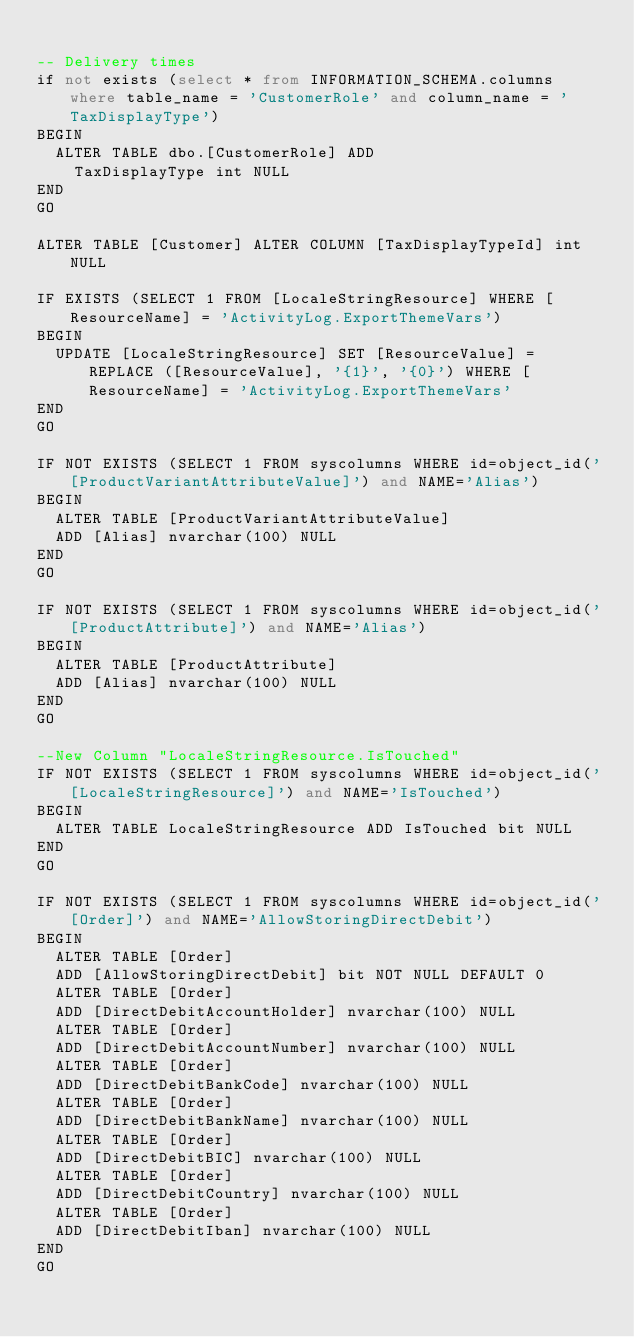Convert code to text. <code><loc_0><loc_0><loc_500><loc_500><_SQL_>
-- Delivery times
if not exists (select * from INFORMATION_SCHEMA.columns where table_name = 'CustomerRole' and column_name = 'TaxDisplayType')
BEGIN
	ALTER TABLE dbo.[CustomerRole] ADD 
		TaxDisplayType int NULL
END
GO

ALTER TABLE [Customer] ALTER COLUMN [TaxDisplayTypeId] int NULL

IF EXISTS (SELECT 1 FROM [LocaleStringResource] WHERE [ResourceName] = 'ActivityLog.ExportThemeVars')
BEGIN
	UPDATE [LocaleStringResource] SET [ResourceValue] = REPLACE ([ResourceValue], '{1}', '{0}') WHERE [ResourceName] = 'ActivityLog.ExportThemeVars'
END
GO

IF NOT EXISTS (SELECT 1 FROM syscolumns WHERE id=object_id('[ProductVariantAttributeValue]') and NAME='Alias')
BEGIN
	ALTER TABLE [ProductVariantAttributeValue]
	ADD [Alias] nvarchar(100) NULL
END
GO

IF NOT EXISTS (SELECT 1 FROM syscolumns WHERE id=object_id('[ProductAttribute]') and NAME='Alias')
BEGIN
	ALTER TABLE [ProductAttribute]
	ADD [Alias] nvarchar(100) NULL
END
GO

--New Column "LocaleStringResource.IsTouched"
IF NOT EXISTS (SELECT 1 FROM syscolumns WHERE id=object_id('[LocaleStringResource]') and NAME='IsTouched')
BEGIN
	ALTER TABLE LocaleStringResource ADD IsTouched bit NULL	
END
GO

IF NOT EXISTS (SELECT 1 FROM syscolumns WHERE id=object_id('[Order]') and NAME='AllowStoringDirectDebit')
BEGIN
	ALTER TABLE [Order]
	ADD [AllowStoringDirectDebit] bit NOT NULL DEFAULT 0
	ALTER TABLE [Order]
	ADD [DirectDebitAccountHolder] nvarchar(100) NULL
	ALTER TABLE [Order]
	ADD [DirectDebitAccountNumber] nvarchar(100) NULL
	ALTER TABLE [Order]
	ADD [DirectDebitBankCode] nvarchar(100) NULL
	ALTER TABLE [Order]
	ADD [DirectDebitBankName] nvarchar(100) NULL
	ALTER TABLE [Order]
	ADD [DirectDebitBIC] nvarchar(100) NULL
	ALTER TABLE [Order]
	ADD [DirectDebitCountry] nvarchar(100) NULL
	ALTER TABLE [Order]
	ADD [DirectDebitIban] nvarchar(100) NULL
END
GO
</code> 